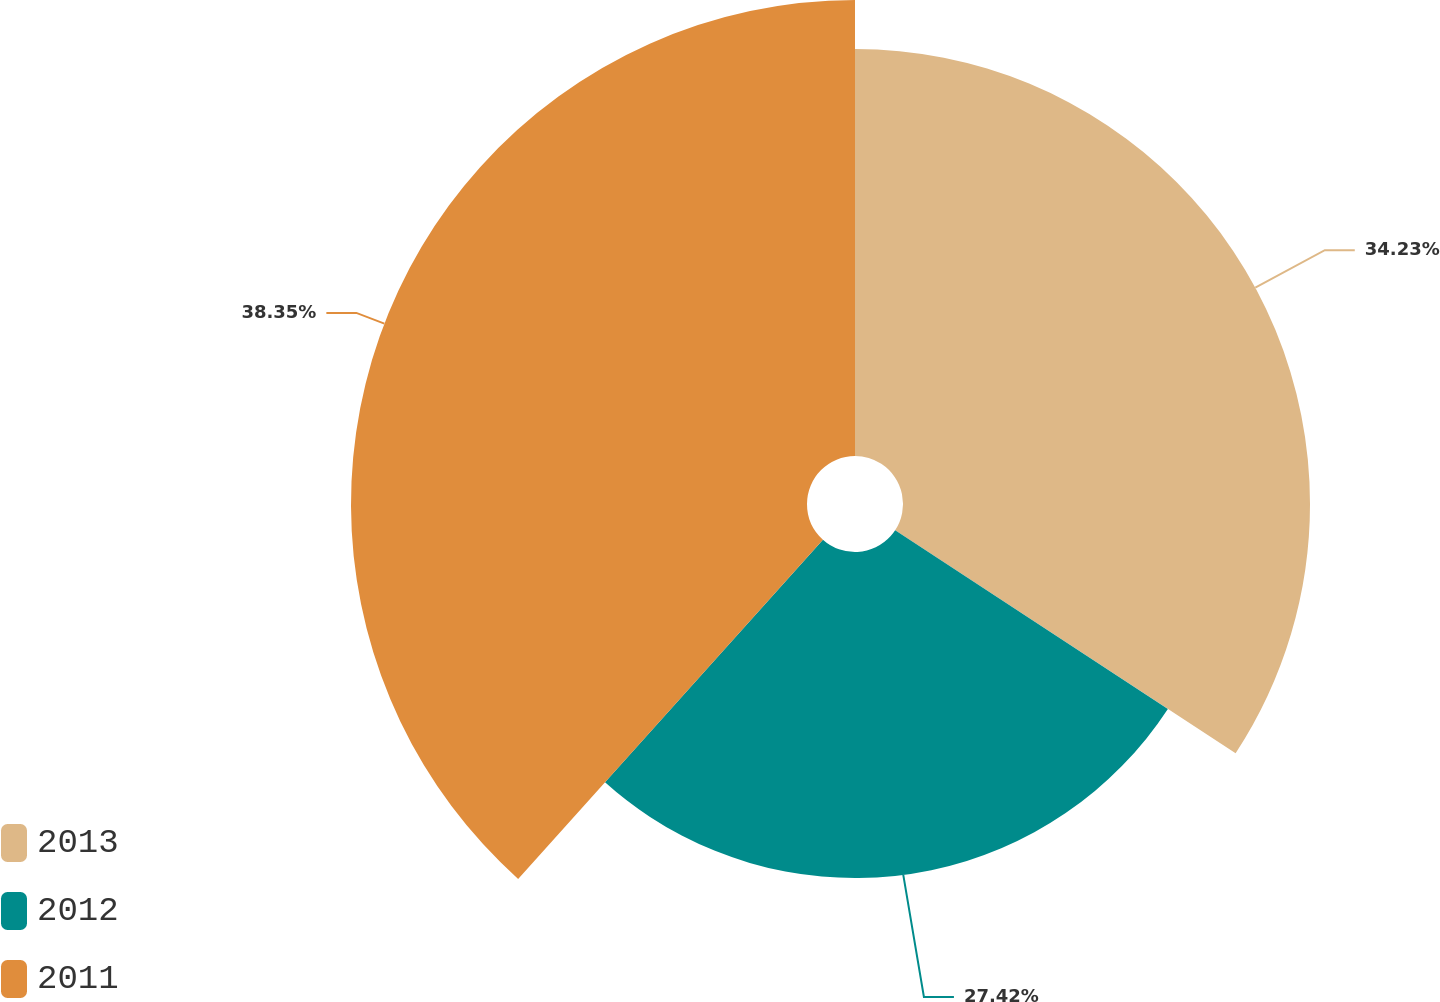Convert chart. <chart><loc_0><loc_0><loc_500><loc_500><pie_chart><fcel>2013<fcel>2012<fcel>2011<nl><fcel>34.23%<fcel>27.42%<fcel>38.35%<nl></chart> 